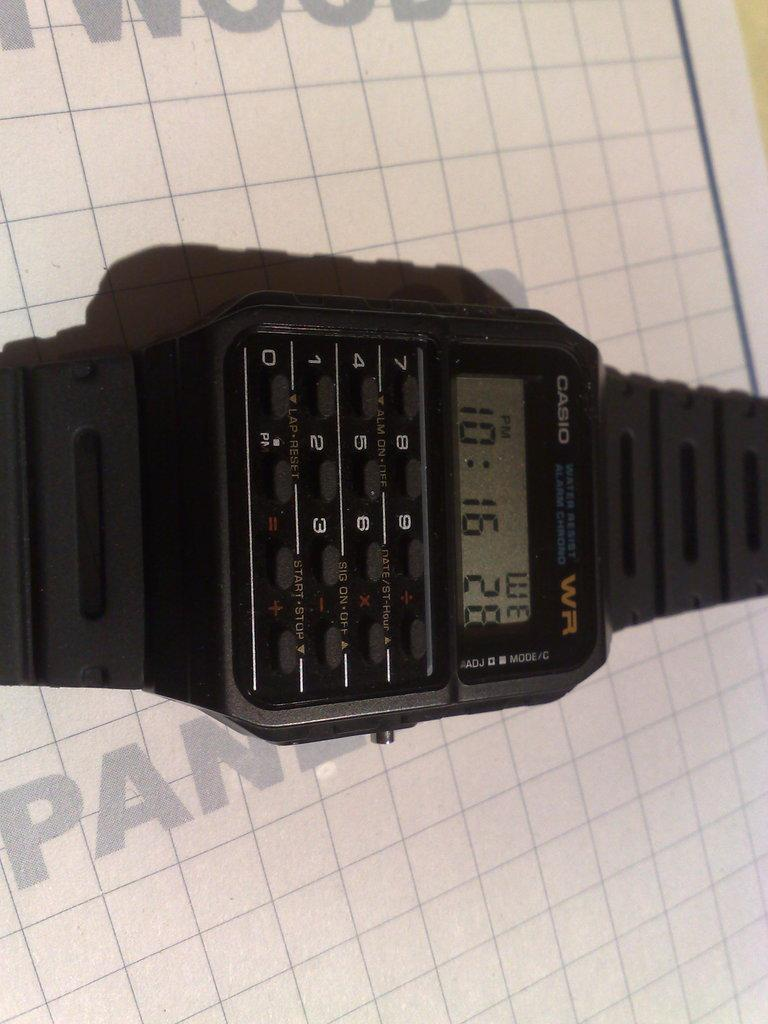<image>
Give a short and clear explanation of the subsequent image. A Casio watch says that it is 10:16 right now. 